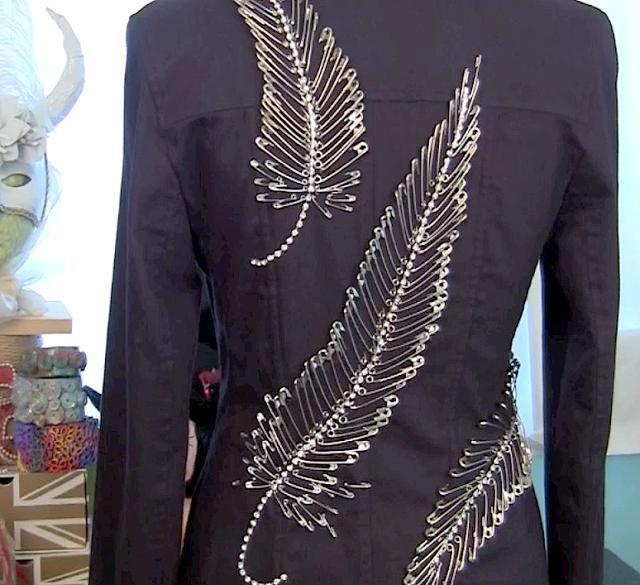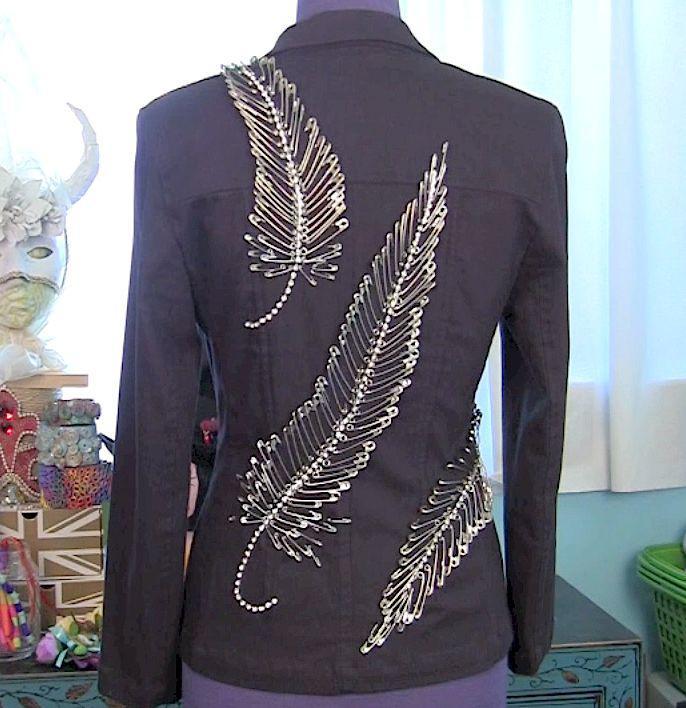The first image is the image on the left, the second image is the image on the right. Considering the images on both sides, is "At least one jacket is sleeveless." valid? Answer yes or no. No. The first image is the image on the left, the second image is the image on the right. For the images displayed, is the sentence "The images show the backs of coats." factually correct? Answer yes or no. Yes. 